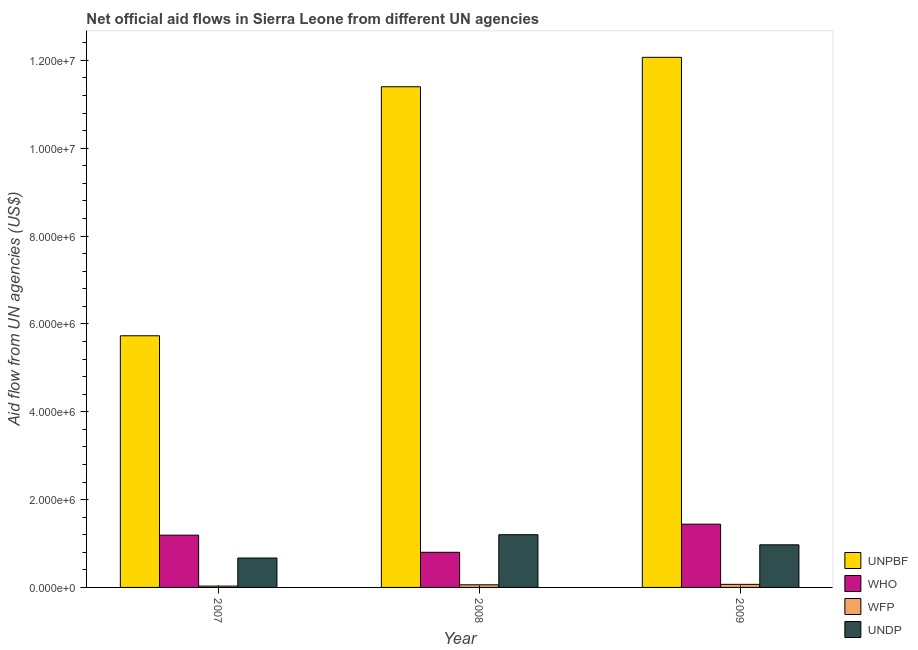How many groups of bars are there?
Offer a terse response. 3. Are the number of bars per tick equal to the number of legend labels?
Keep it short and to the point. Yes. How many bars are there on the 3rd tick from the left?
Your response must be concise. 4. How many bars are there on the 2nd tick from the right?
Keep it short and to the point. 4. What is the label of the 1st group of bars from the left?
Provide a short and direct response. 2007. In how many cases, is the number of bars for a given year not equal to the number of legend labels?
Your answer should be very brief. 0. What is the amount of aid given by who in 2008?
Keep it short and to the point. 8.00e+05. Across all years, what is the maximum amount of aid given by who?
Give a very brief answer. 1.44e+06. Across all years, what is the minimum amount of aid given by unpbf?
Offer a very short reply. 5.73e+06. What is the total amount of aid given by undp in the graph?
Your answer should be compact. 2.84e+06. What is the difference between the amount of aid given by wfp in 2007 and that in 2008?
Keep it short and to the point. -3.00e+04. What is the difference between the amount of aid given by wfp in 2008 and the amount of aid given by undp in 2009?
Keep it short and to the point. -10000. What is the average amount of aid given by undp per year?
Provide a succinct answer. 9.47e+05. In the year 2007, what is the difference between the amount of aid given by wfp and amount of aid given by undp?
Provide a succinct answer. 0. In how many years, is the amount of aid given by undp greater than 4000000 US$?
Your answer should be compact. 0. What is the ratio of the amount of aid given by unpbf in 2007 to that in 2009?
Keep it short and to the point. 0.47. Is the amount of aid given by who in 2007 less than that in 2008?
Your answer should be very brief. No. What is the difference between the highest and the lowest amount of aid given by unpbf?
Offer a very short reply. 6.34e+06. Is it the case that in every year, the sum of the amount of aid given by wfp and amount of aid given by undp is greater than the sum of amount of aid given by who and amount of aid given by unpbf?
Offer a terse response. No. What does the 3rd bar from the left in 2008 represents?
Give a very brief answer. WFP. What does the 4th bar from the right in 2008 represents?
Your response must be concise. UNPBF. Is it the case that in every year, the sum of the amount of aid given by unpbf and amount of aid given by who is greater than the amount of aid given by wfp?
Your response must be concise. Yes. How many years are there in the graph?
Offer a very short reply. 3. Does the graph contain any zero values?
Give a very brief answer. No. Where does the legend appear in the graph?
Provide a succinct answer. Bottom right. How many legend labels are there?
Ensure brevity in your answer.  4. How are the legend labels stacked?
Give a very brief answer. Vertical. What is the title of the graph?
Your answer should be compact. Net official aid flows in Sierra Leone from different UN agencies. What is the label or title of the X-axis?
Ensure brevity in your answer.  Year. What is the label or title of the Y-axis?
Provide a short and direct response. Aid flow from UN agencies (US$). What is the Aid flow from UN agencies (US$) in UNPBF in 2007?
Provide a short and direct response. 5.73e+06. What is the Aid flow from UN agencies (US$) of WHO in 2007?
Offer a very short reply. 1.19e+06. What is the Aid flow from UN agencies (US$) of UNDP in 2007?
Offer a very short reply. 6.70e+05. What is the Aid flow from UN agencies (US$) in UNPBF in 2008?
Keep it short and to the point. 1.14e+07. What is the Aid flow from UN agencies (US$) in WFP in 2008?
Provide a short and direct response. 6.00e+04. What is the Aid flow from UN agencies (US$) in UNDP in 2008?
Give a very brief answer. 1.20e+06. What is the Aid flow from UN agencies (US$) of UNPBF in 2009?
Your response must be concise. 1.21e+07. What is the Aid flow from UN agencies (US$) of WHO in 2009?
Provide a short and direct response. 1.44e+06. What is the Aid flow from UN agencies (US$) in UNDP in 2009?
Provide a succinct answer. 9.70e+05. Across all years, what is the maximum Aid flow from UN agencies (US$) in UNPBF?
Offer a terse response. 1.21e+07. Across all years, what is the maximum Aid flow from UN agencies (US$) of WHO?
Offer a terse response. 1.44e+06. Across all years, what is the maximum Aid flow from UN agencies (US$) of WFP?
Your answer should be compact. 7.00e+04. Across all years, what is the maximum Aid flow from UN agencies (US$) of UNDP?
Provide a short and direct response. 1.20e+06. Across all years, what is the minimum Aid flow from UN agencies (US$) in UNPBF?
Your response must be concise. 5.73e+06. Across all years, what is the minimum Aid flow from UN agencies (US$) of UNDP?
Offer a terse response. 6.70e+05. What is the total Aid flow from UN agencies (US$) in UNPBF in the graph?
Keep it short and to the point. 2.92e+07. What is the total Aid flow from UN agencies (US$) of WHO in the graph?
Offer a very short reply. 3.43e+06. What is the total Aid flow from UN agencies (US$) of WFP in the graph?
Your answer should be compact. 1.60e+05. What is the total Aid flow from UN agencies (US$) of UNDP in the graph?
Offer a very short reply. 2.84e+06. What is the difference between the Aid flow from UN agencies (US$) of UNPBF in 2007 and that in 2008?
Keep it short and to the point. -5.67e+06. What is the difference between the Aid flow from UN agencies (US$) in WHO in 2007 and that in 2008?
Offer a terse response. 3.90e+05. What is the difference between the Aid flow from UN agencies (US$) in UNDP in 2007 and that in 2008?
Your answer should be compact. -5.30e+05. What is the difference between the Aid flow from UN agencies (US$) in UNPBF in 2007 and that in 2009?
Offer a very short reply. -6.34e+06. What is the difference between the Aid flow from UN agencies (US$) of WHO in 2007 and that in 2009?
Offer a terse response. -2.50e+05. What is the difference between the Aid flow from UN agencies (US$) of UNPBF in 2008 and that in 2009?
Your response must be concise. -6.70e+05. What is the difference between the Aid flow from UN agencies (US$) of WHO in 2008 and that in 2009?
Make the answer very short. -6.40e+05. What is the difference between the Aid flow from UN agencies (US$) in UNPBF in 2007 and the Aid flow from UN agencies (US$) in WHO in 2008?
Your answer should be very brief. 4.93e+06. What is the difference between the Aid flow from UN agencies (US$) of UNPBF in 2007 and the Aid flow from UN agencies (US$) of WFP in 2008?
Provide a succinct answer. 5.67e+06. What is the difference between the Aid flow from UN agencies (US$) of UNPBF in 2007 and the Aid flow from UN agencies (US$) of UNDP in 2008?
Provide a short and direct response. 4.53e+06. What is the difference between the Aid flow from UN agencies (US$) in WHO in 2007 and the Aid flow from UN agencies (US$) in WFP in 2008?
Provide a succinct answer. 1.13e+06. What is the difference between the Aid flow from UN agencies (US$) in WFP in 2007 and the Aid flow from UN agencies (US$) in UNDP in 2008?
Provide a succinct answer. -1.17e+06. What is the difference between the Aid flow from UN agencies (US$) of UNPBF in 2007 and the Aid flow from UN agencies (US$) of WHO in 2009?
Offer a very short reply. 4.29e+06. What is the difference between the Aid flow from UN agencies (US$) of UNPBF in 2007 and the Aid flow from UN agencies (US$) of WFP in 2009?
Give a very brief answer. 5.66e+06. What is the difference between the Aid flow from UN agencies (US$) in UNPBF in 2007 and the Aid flow from UN agencies (US$) in UNDP in 2009?
Your answer should be compact. 4.76e+06. What is the difference between the Aid flow from UN agencies (US$) of WHO in 2007 and the Aid flow from UN agencies (US$) of WFP in 2009?
Your response must be concise. 1.12e+06. What is the difference between the Aid flow from UN agencies (US$) of WHO in 2007 and the Aid flow from UN agencies (US$) of UNDP in 2009?
Keep it short and to the point. 2.20e+05. What is the difference between the Aid flow from UN agencies (US$) of WFP in 2007 and the Aid flow from UN agencies (US$) of UNDP in 2009?
Offer a terse response. -9.40e+05. What is the difference between the Aid flow from UN agencies (US$) of UNPBF in 2008 and the Aid flow from UN agencies (US$) of WHO in 2009?
Your answer should be very brief. 9.96e+06. What is the difference between the Aid flow from UN agencies (US$) in UNPBF in 2008 and the Aid flow from UN agencies (US$) in WFP in 2009?
Your answer should be compact. 1.13e+07. What is the difference between the Aid flow from UN agencies (US$) in UNPBF in 2008 and the Aid flow from UN agencies (US$) in UNDP in 2009?
Provide a short and direct response. 1.04e+07. What is the difference between the Aid flow from UN agencies (US$) in WHO in 2008 and the Aid flow from UN agencies (US$) in WFP in 2009?
Give a very brief answer. 7.30e+05. What is the difference between the Aid flow from UN agencies (US$) in WHO in 2008 and the Aid flow from UN agencies (US$) in UNDP in 2009?
Keep it short and to the point. -1.70e+05. What is the difference between the Aid flow from UN agencies (US$) of WFP in 2008 and the Aid flow from UN agencies (US$) of UNDP in 2009?
Provide a succinct answer. -9.10e+05. What is the average Aid flow from UN agencies (US$) in UNPBF per year?
Offer a terse response. 9.73e+06. What is the average Aid flow from UN agencies (US$) in WHO per year?
Give a very brief answer. 1.14e+06. What is the average Aid flow from UN agencies (US$) in WFP per year?
Offer a very short reply. 5.33e+04. What is the average Aid flow from UN agencies (US$) of UNDP per year?
Provide a short and direct response. 9.47e+05. In the year 2007, what is the difference between the Aid flow from UN agencies (US$) of UNPBF and Aid flow from UN agencies (US$) of WHO?
Make the answer very short. 4.54e+06. In the year 2007, what is the difference between the Aid flow from UN agencies (US$) of UNPBF and Aid flow from UN agencies (US$) of WFP?
Your answer should be compact. 5.70e+06. In the year 2007, what is the difference between the Aid flow from UN agencies (US$) of UNPBF and Aid flow from UN agencies (US$) of UNDP?
Make the answer very short. 5.06e+06. In the year 2007, what is the difference between the Aid flow from UN agencies (US$) of WHO and Aid flow from UN agencies (US$) of WFP?
Your answer should be very brief. 1.16e+06. In the year 2007, what is the difference between the Aid flow from UN agencies (US$) in WHO and Aid flow from UN agencies (US$) in UNDP?
Keep it short and to the point. 5.20e+05. In the year 2007, what is the difference between the Aid flow from UN agencies (US$) of WFP and Aid flow from UN agencies (US$) of UNDP?
Ensure brevity in your answer.  -6.40e+05. In the year 2008, what is the difference between the Aid flow from UN agencies (US$) in UNPBF and Aid flow from UN agencies (US$) in WHO?
Your response must be concise. 1.06e+07. In the year 2008, what is the difference between the Aid flow from UN agencies (US$) in UNPBF and Aid flow from UN agencies (US$) in WFP?
Your response must be concise. 1.13e+07. In the year 2008, what is the difference between the Aid flow from UN agencies (US$) of UNPBF and Aid flow from UN agencies (US$) of UNDP?
Give a very brief answer. 1.02e+07. In the year 2008, what is the difference between the Aid flow from UN agencies (US$) in WHO and Aid flow from UN agencies (US$) in WFP?
Make the answer very short. 7.40e+05. In the year 2008, what is the difference between the Aid flow from UN agencies (US$) in WHO and Aid flow from UN agencies (US$) in UNDP?
Provide a succinct answer. -4.00e+05. In the year 2008, what is the difference between the Aid flow from UN agencies (US$) of WFP and Aid flow from UN agencies (US$) of UNDP?
Your answer should be compact. -1.14e+06. In the year 2009, what is the difference between the Aid flow from UN agencies (US$) in UNPBF and Aid flow from UN agencies (US$) in WHO?
Your answer should be very brief. 1.06e+07. In the year 2009, what is the difference between the Aid flow from UN agencies (US$) of UNPBF and Aid flow from UN agencies (US$) of UNDP?
Your answer should be very brief. 1.11e+07. In the year 2009, what is the difference between the Aid flow from UN agencies (US$) in WHO and Aid flow from UN agencies (US$) in WFP?
Your answer should be very brief. 1.37e+06. In the year 2009, what is the difference between the Aid flow from UN agencies (US$) in WFP and Aid flow from UN agencies (US$) in UNDP?
Your response must be concise. -9.00e+05. What is the ratio of the Aid flow from UN agencies (US$) in UNPBF in 2007 to that in 2008?
Make the answer very short. 0.5. What is the ratio of the Aid flow from UN agencies (US$) in WHO in 2007 to that in 2008?
Offer a very short reply. 1.49. What is the ratio of the Aid flow from UN agencies (US$) in WFP in 2007 to that in 2008?
Give a very brief answer. 0.5. What is the ratio of the Aid flow from UN agencies (US$) in UNDP in 2007 to that in 2008?
Provide a succinct answer. 0.56. What is the ratio of the Aid flow from UN agencies (US$) of UNPBF in 2007 to that in 2009?
Provide a short and direct response. 0.47. What is the ratio of the Aid flow from UN agencies (US$) of WHO in 2007 to that in 2009?
Your answer should be very brief. 0.83. What is the ratio of the Aid flow from UN agencies (US$) in WFP in 2007 to that in 2009?
Your response must be concise. 0.43. What is the ratio of the Aid flow from UN agencies (US$) of UNDP in 2007 to that in 2009?
Your answer should be very brief. 0.69. What is the ratio of the Aid flow from UN agencies (US$) of UNPBF in 2008 to that in 2009?
Provide a succinct answer. 0.94. What is the ratio of the Aid flow from UN agencies (US$) of WHO in 2008 to that in 2009?
Provide a short and direct response. 0.56. What is the ratio of the Aid flow from UN agencies (US$) in UNDP in 2008 to that in 2009?
Ensure brevity in your answer.  1.24. What is the difference between the highest and the second highest Aid flow from UN agencies (US$) in UNPBF?
Offer a terse response. 6.70e+05. What is the difference between the highest and the second highest Aid flow from UN agencies (US$) of WHO?
Keep it short and to the point. 2.50e+05. What is the difference between the highest and the second highest Aid flow from UN agencies (US$) in UNDP?
Provide a succinct answer. 2.30e+05. What is the difference between the highest and the lowest Aid flow from UN agencies (US$) in UNPBF?
Keep it short and to the point. 6.34e+06. What is the difference between the highest and the lowest Aid flow from UN agencies (US$) in WHO?
Give a very brief answer. 6.40e+05. What is the difference between the highest and the lowest Aid flow from UN agencies (US$) in WFP?
Your answer should be very brief. 4.00e+04. What is the difference between the highest and the lowest Aid flow from UN agencies (US$) of UNDP?
Give a very brief answer. 5.30e+05. 